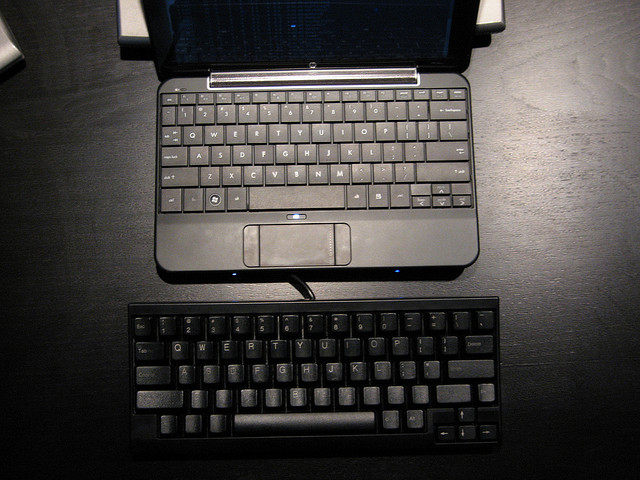<image>Why are there two keyboards? I don't know why there are two keyboards. It can be for two computers or for improved functionality. Why are there two keyboards? I don't know why there are two keyboards. It could be for different purposes, such as improved functionality or for use with two computers. 